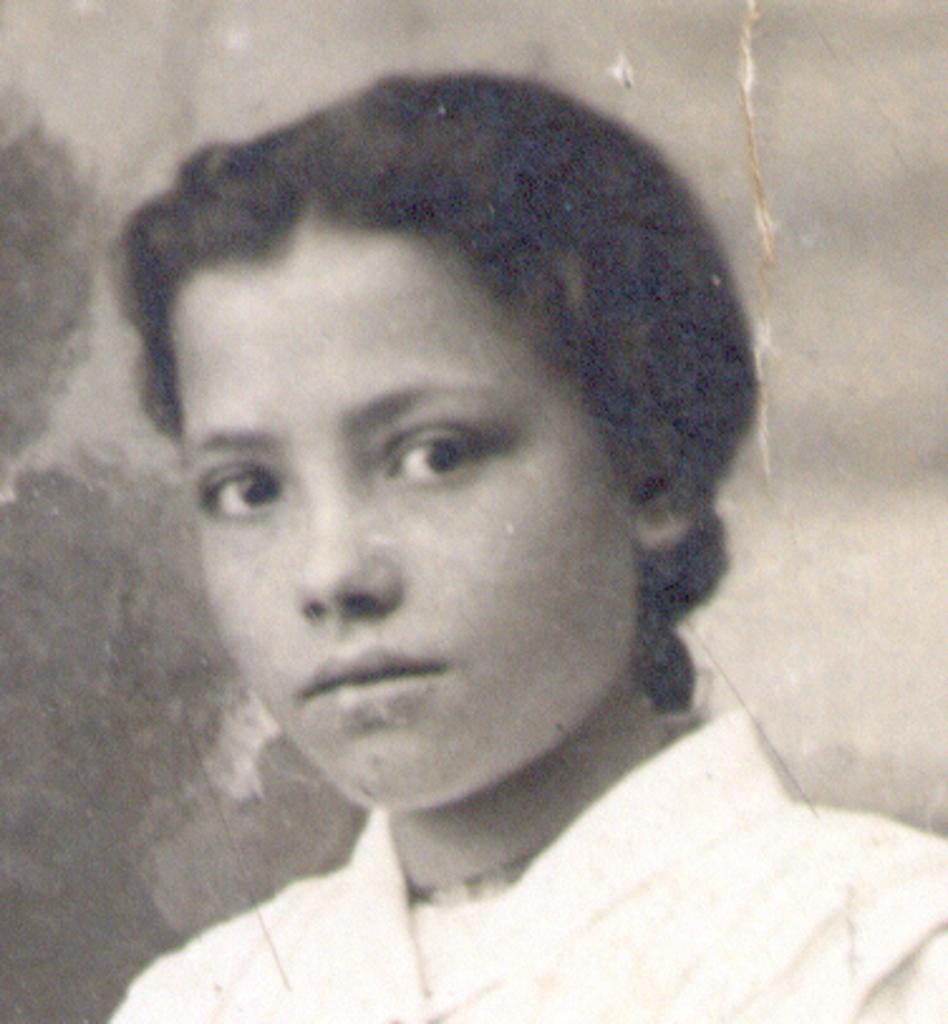Can you describe this image briefly? This is a black and white image. In which, there is a person in a dress, smiling. And the background is blurred. 